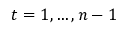<formula> <loc_0><loc_0><loc_500><loc_500>t = 1 , \dots , n - 1</formula> 